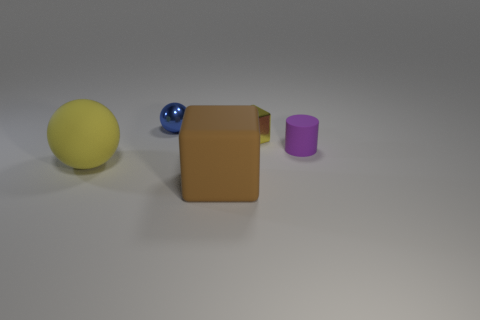Subtract all purple spheres. Subtract all brown cylinders. How many spheres are left? 2 Add 5 tiny things. How many objects exist? 10 Subtract all balls. How many objects are left? 3 Add 3 large rubber balls. How many large rubber balls are left? 4 Add 5 purple matte cylinders. How many purple matte cylinders exist? 6 Subtract 0 green cylinders. How many objects are left? 5 Subtract all big blue cylinders. Subtract all big rubber things. How many objects are left? 3 